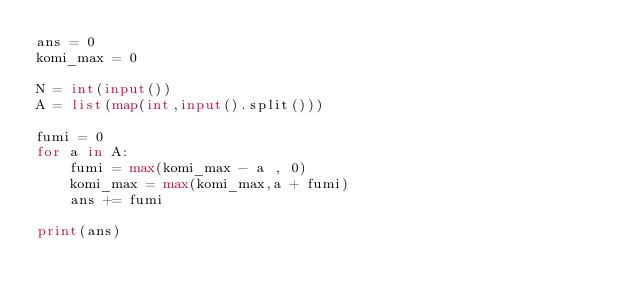Convert code to text. <code><loc_0><loc_0><loc_500><loc_500><_Python_>ans = 0
komi_max = 0

N = int(input())
A = list(map(int,input().split()))

fumi = 0
for a in A:
    fumi = max(komi_max - a , 0)
    komi_max = max(komi_max,a + fumi)
    ans += fumi

print(ans)</code> 